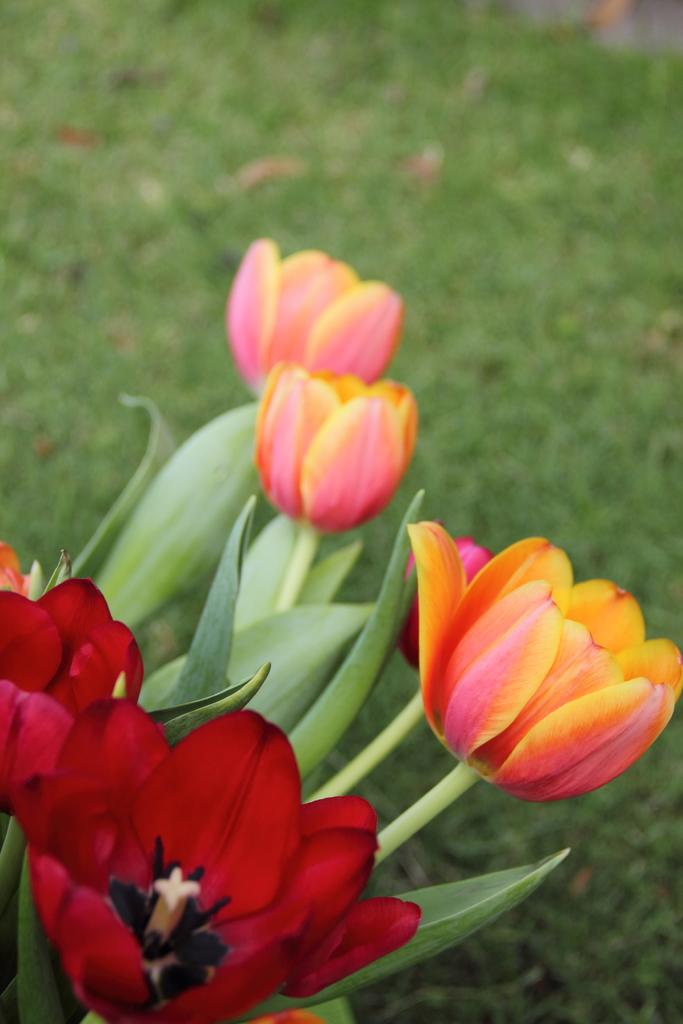What type of plants can be seen in the image? The image contains flowers. What colors are the flowers in the image? There are red and orange flowers in the image. What is the color of the grass in the image? The grass on the ground in the image is green. What type of appliance can be seen in the image? There is no appliance present in the image; it features flowers and green grass. What type of soap is used to clean the flowers in the image? There is no soap or cleaning activity depicted in the image; it simply shows flowers and green grass. 